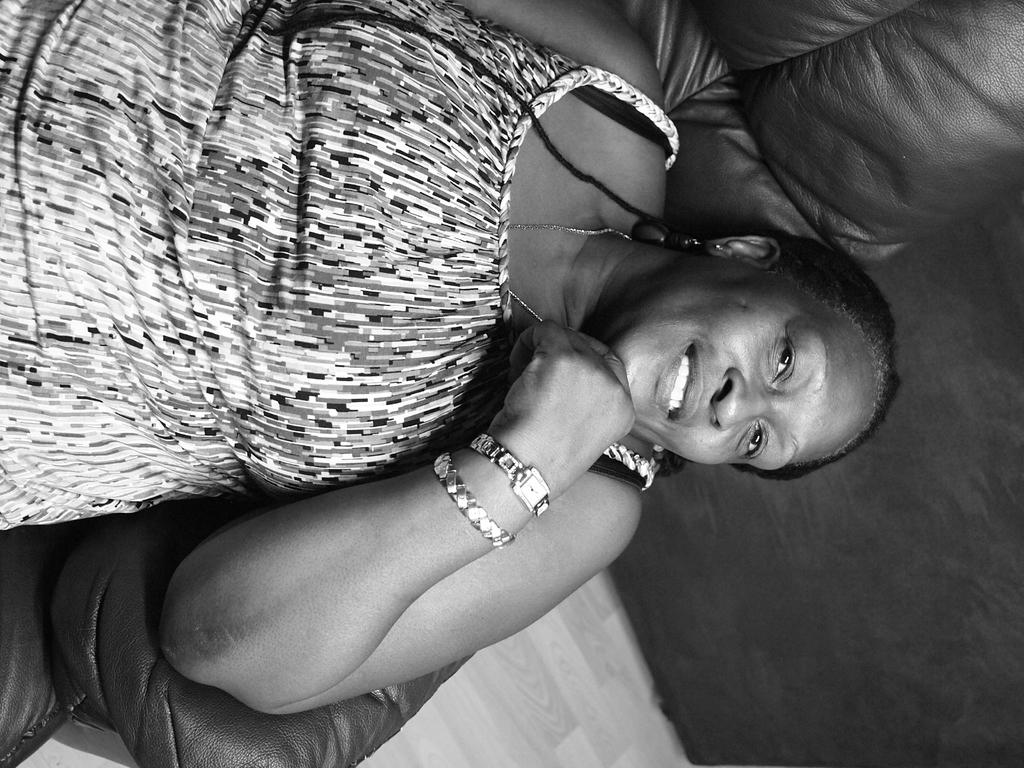What is the main subject of the image? The main subject of the image is a woman. What is the woman doing in the image? The woman is sitting on a sofa. What is the woman's facial expression in the image? The woman is smiling. What type of wine is the woman holding in the image? There is no wine present in the image; the woman is not holding any wine. 